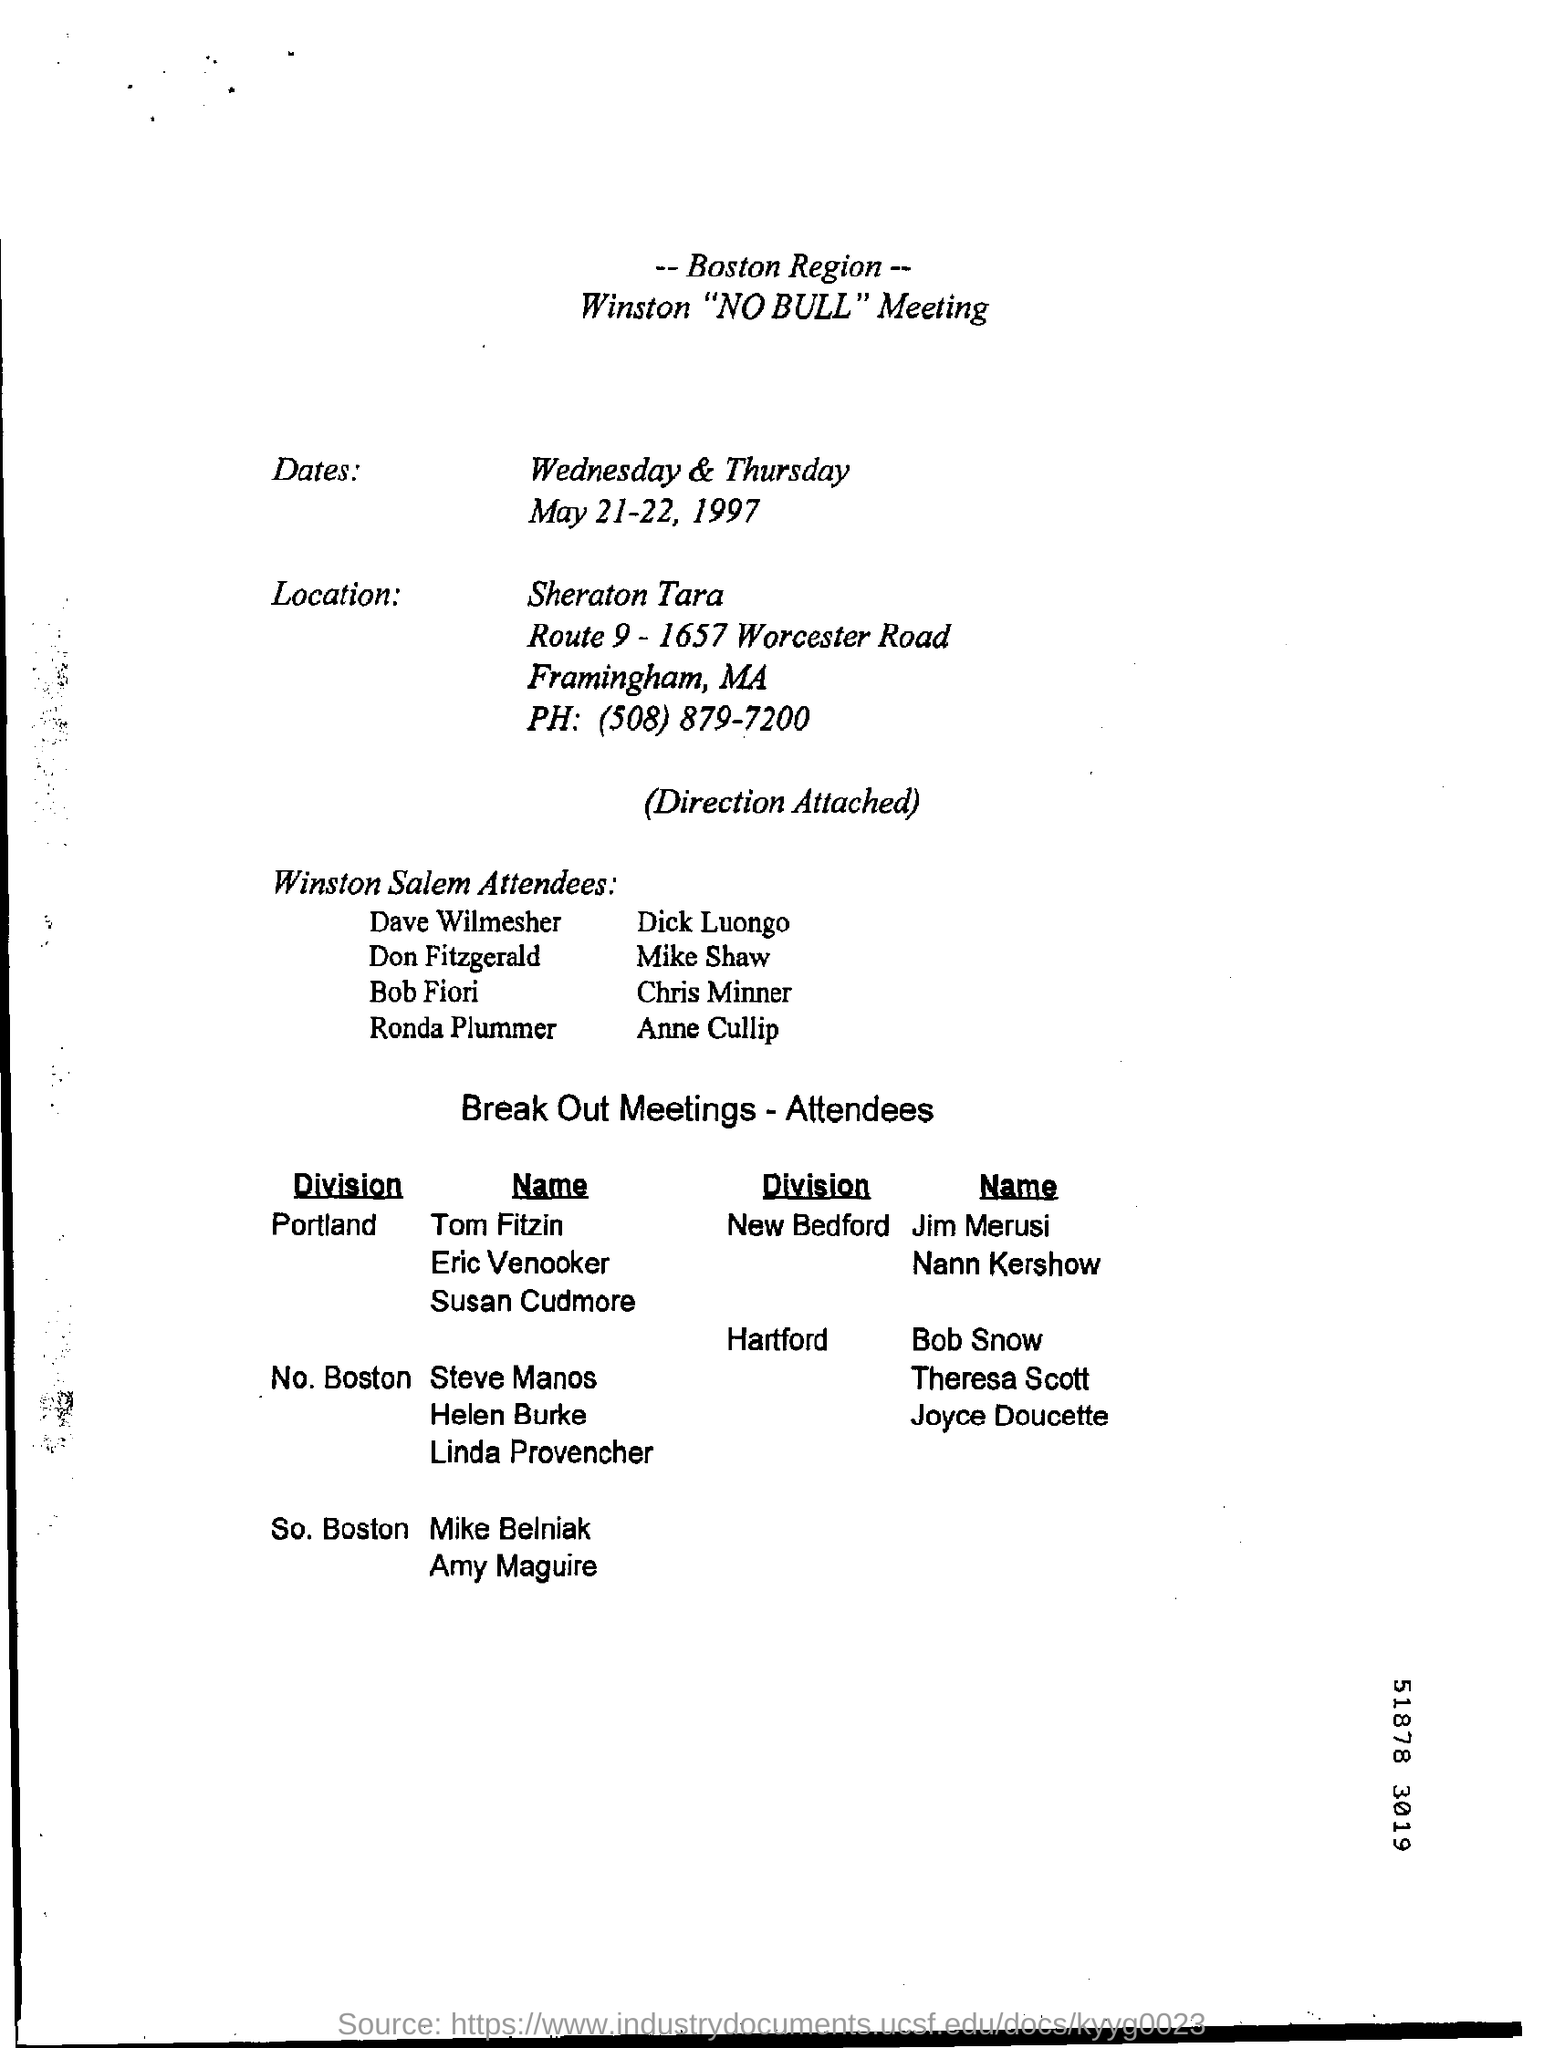Indicate a few pertinent items in this graphic. The title of the meeting is "What is the Title of the Meeting? Winston "NO BULL" Meeting. 